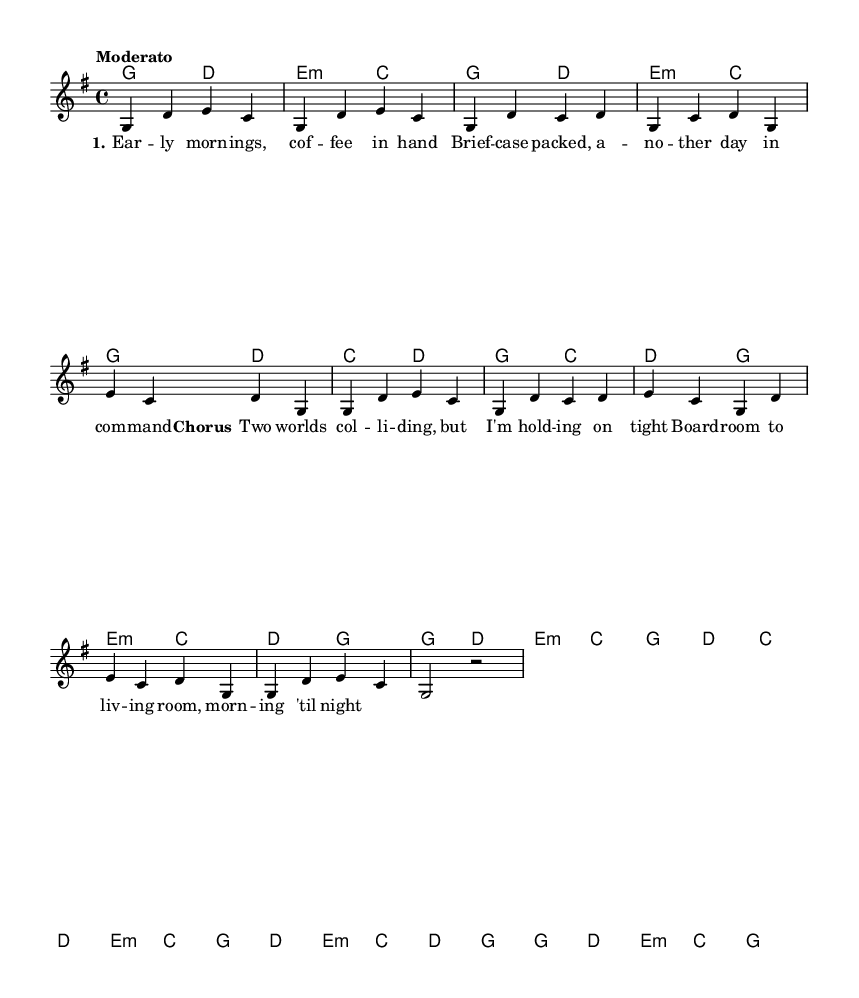What is the key signature of this music? The key signature is G major, which has one sharp (F#). This can be determined by analyzing the beginning of the staff where the key signature is indicated.
Answer: G major What is the time signature of this music? The time signature is 4/4, which appears at the beginning of the score. It indicates that there are four beats in each measure and a quarter note receives one beat.
Answer: 4/4 What is the tempo marking of this music? The tempo marking is "Moderato," which can be found written at the beginning of the score. This indicates a moderate speed for the piece.
Answer: Moderato How many measures are there in the chorus section? To find the number of measures in the chorus, we can count them in the score. The chorus is represented with notated music, consisting of four measures.
Answer: Four Which chord appears as the last chord in the melody? By examining the harmony part written at the end of the score, the last chord is G major. This is seen in the final chord of the harmony section, which corresponds to the melody.
Answer: G major What lyrical theme is expressed in the first verse? The first verse deals with the busy life of balancing work and family, described through imagery of mornings and daily routines involving coffee and briefcases. This thematic element can be inferred from the lyrics presented in the score.
Answer: Balancing work and family How does the bridge differ musically from the chorus? The bridge introduces different chords and a varied melody compared to the chorus, creating a contrast. This requires analyzing both sections for their harmonic and melodic changes to see how they diverge in musical style.
Answer: Different chords and melody 